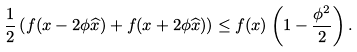Convert formula to latex. <formula><loc_0><loc_0><loc_500><loc_500>\frac { 1 } { 2 } \left ( f ( x - 2 \phi \widehat { x } ) + f ( x + 2 \phi \widehat { x } ) \right ) \leq f ( x ) \left ( 1 - \frac { \phi ^ { 2 } } { 2 } \right ) .</formula> 